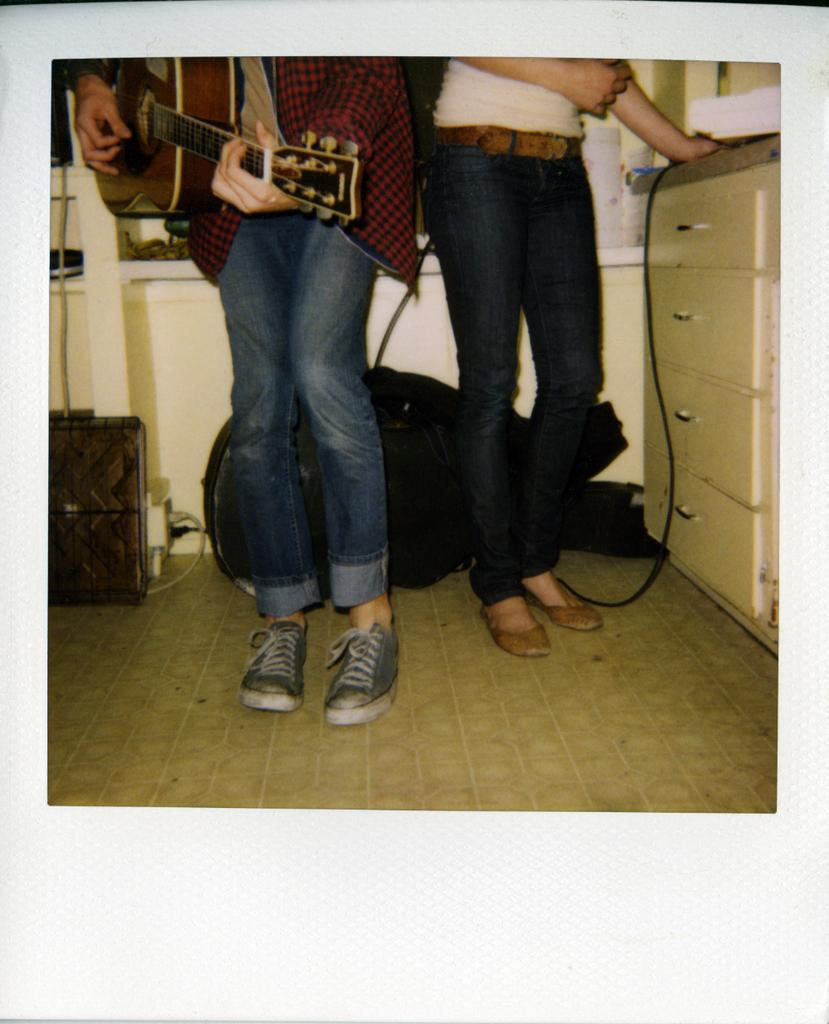What is the person in the image doing with the guitar? The person is playing the guitar. Can you describe the lady in the image? The lady is standing on the floor in the image. What can be seen in the background of the image? There are bags visible in the background of the image. What type of juice is being squeezed by the person in the image? There is no juice or squeezing activity present in the image; the person is playing a guitar. What kind of bean is visible on the floor near the lady in the image? There are no beans visible in the image; the lady is standing on the floor, and there is no mention of beans in the provided facts. 